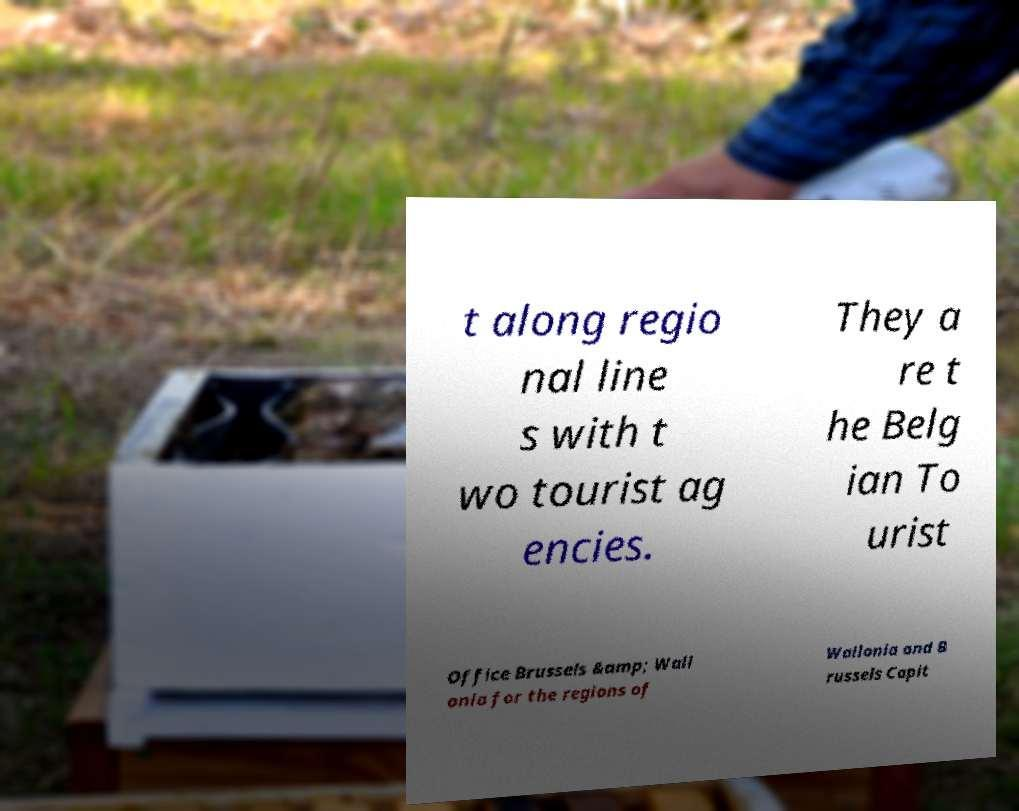I need the written content from this picture converted into text. Can you do that? t along regio nal line s with t wo tourist ag encies. They a re t he Belg ian To urist Office Brussels &amp; Wall onia for the regions of Wallonia and B russels Capit 